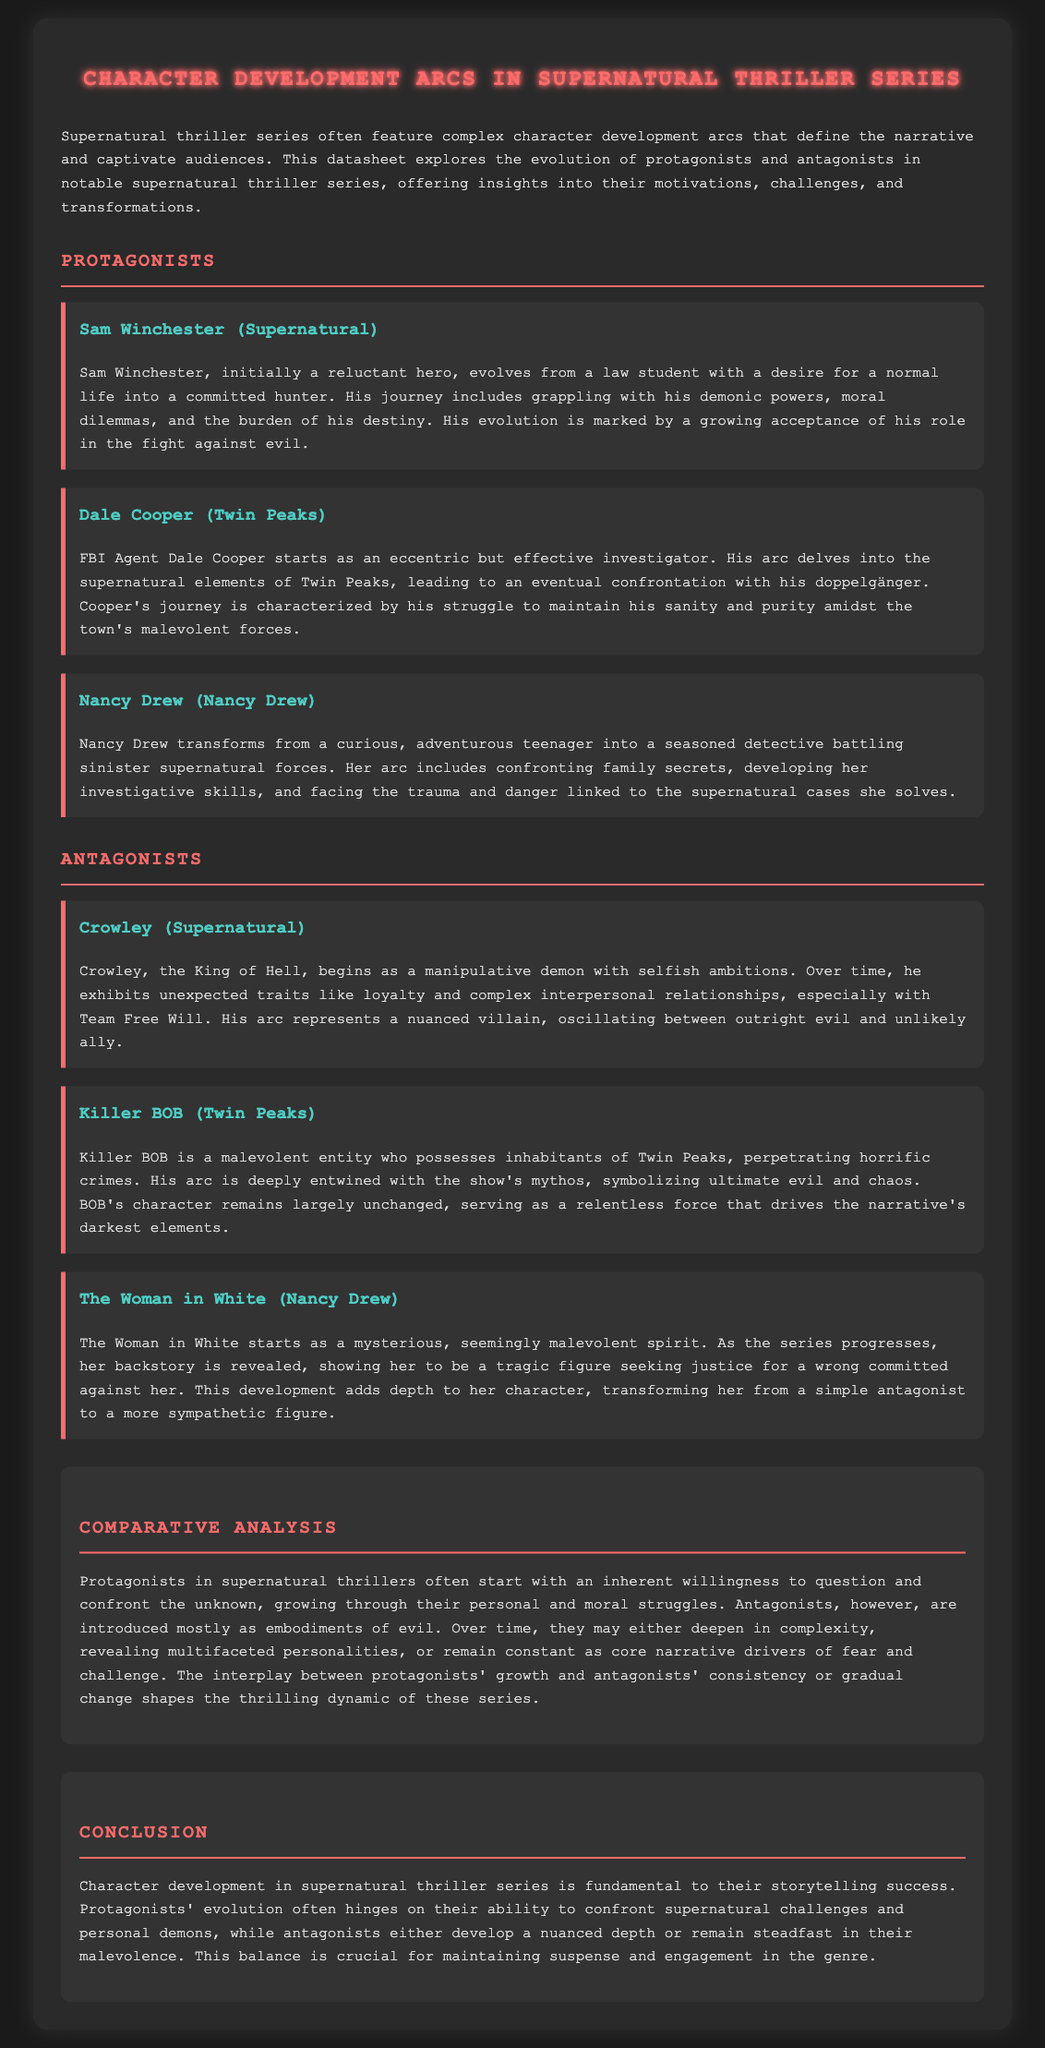What is the name of the protagonist from "Supernatural"? Sam Winchester is identified as the protagonist from the series "Supernatural" within the document.
Answer: Sam Winchester Who does Dale Cooper confront in "Twin Peaks"? The document states that Dale Cooper confronts his doppelgänger, indicating the character's significant arc.
Answer: his doppelgänger What supernatural entity is associated with "Twin Peaks"? Killer BOB is mentioned as a malevolent entity connected to "Twin Peaks" in the document.
Answer: Killer BOB In which series does Nancy Drew appear? The document clearly states that Nancy Drew is the protagonist in the series "Nancy Drew".
Answer: Nancy Drew Who is characterized as the King of Hell in "Supernatural"? Crowley is explicitly mentioned as the King of Hell in the document, indicating his role in the series.
Answer: Crowley What is a key characteristic of Killer BOB’s arc? Killer BOB is characterized as a relentless force that symbolizes ultimate evil and chaos throughout the narrative.
Answer: ultimate evil and chaos How does the Woman in White's character evolve? The document describes that the Woman in White transforms from a seemingly malevolent spirit to a more sympathetic figure as her backstory is revealed.
Answer: more sympathetic figure What do protagonists in supernatural thrillers often begin with? The document states that protagonists typically start with an inherent willingness to question and confront the unknown.
Answer: inherent willingness What does the comparative analysis highlight about antagonists? The comparative analysis notes that antagonists may reveal multifaceted personalities or remain constant as core narrative drivers.
Answer: multifaceted personalities or remain constant What is fundamental to storytelling success in supernatural thrillers? The conclusion states that character development is fundamental to storytelling success in supernatural thrillers, emphasizing protagonists' and antagonists' arcs.
Answer: character development 